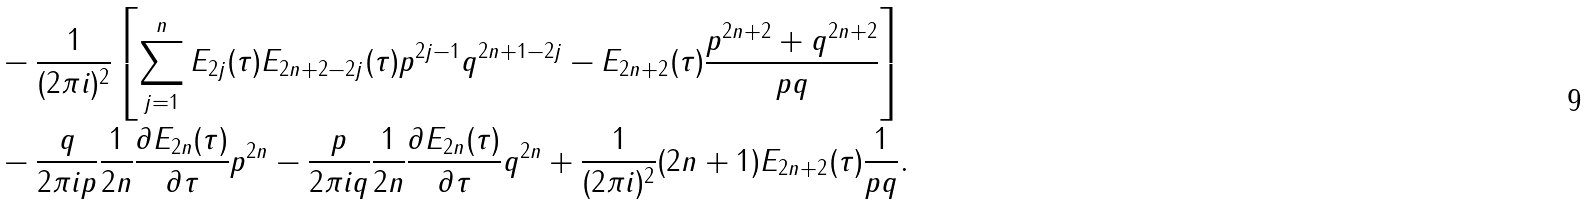<formula> <loc_0><loc_0><loc_500><loc_500>& - \frac { 1 } { ( 2 \pi i ) ^ { 2 } } \left [ \sum _ { j = 1 } ^ { n } E _ { 2 j } ( \tau ) E _ { 2 n + 2 - 2 j } ( \tau ) p ^ { 2 j - 1 } q ^ { 2 n + 1 - 2 j } - E _ { 2 n + 2 } ( \tau ) \frac { p ^ { 2 n + 2 } + q ^ { 2 n + 2 } } { p q } \right ] \\ & - \frac { q } { 2 \pi i p } \frac { 1 } { 2 n } \frac { \partial E _ { 2 n } ( \tau ) } { \partial \tau } p ^ { 2 n } - \frac { p } { 2 \pi i q } \frac { 1 } { 2 n } \frac { \partial E _ { 2 n } ( \tau ) } { \partial \tau } q ^ { 2 n } + \frac { 1 } { ( 2 \pi i ) ^ { 2 } } ( 2 n + 1 ) E _ { 2 n + 2 } ( \tau ) \frac { 1 } { p q } .</formula> 